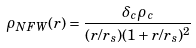<formula> <loc_0><loc_0><loc_500><loc_500>\rho _ { N F W } ( r ) = \frac { \delta _ { c } \rho _ { c } } { ( r / r _ { s } ) ( 1 + r / r _ { s } ) ^ { 2 } }</formula> 